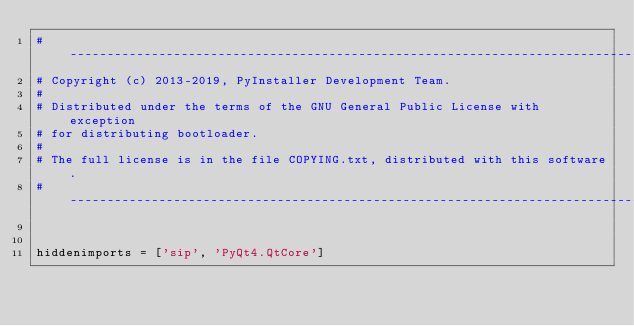<code> <loc_0><loc_0><loc_500><loc_500><_Python_>#-----------------------------------------------------------------------------
# Copyright (c) 2013-2019, PyInstaller Development Team.
#
# Distributed under the terms of the GNU General Public License with exception
# for distributing bootloader.
#
# The full license is in the file COPYING.txt, distributed with this software.
#-----------------------------------------------------------------------------


hiddenimports = ['sip', 'PyQt4.QtCore']

</code> 